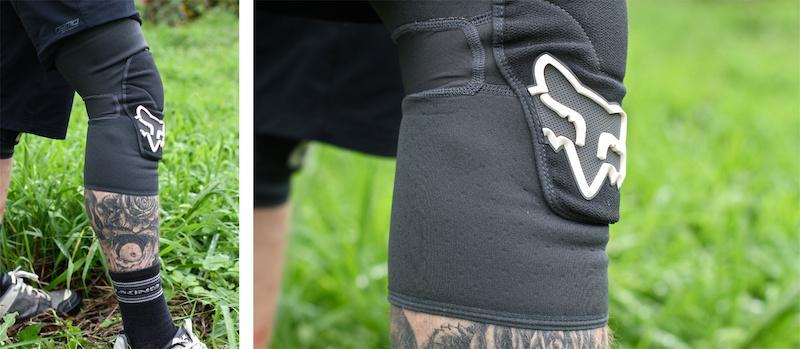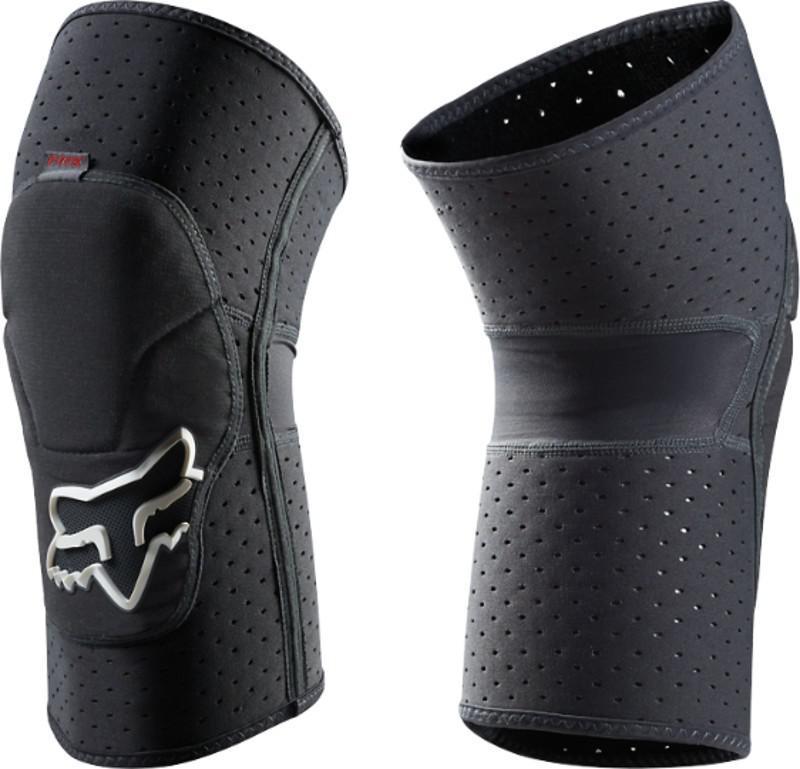The first image is the image on the left, the second image is the image on the right. Given the left and right images, does the statement "One image shows what the back side of the knee pad looks like." hold true? Answer yes or no. Yes. 